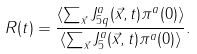Convert formula to latex. <formula><loc_0><loc_0><loc_500><loc_500>R ( t ) = \frac { \langle \sum _ { \vec { x } } J ^ { a } _ { 5 q } ( \vec { x } , t ) \pi ^ { a } ( 0 ) \rangle } { \langle \sum _ { \vec { x } } J ^ { a } _ { 5 } ( \vec { x } , t ) \pi ^ { a } ( 0 ) \rangle } .</formula> 